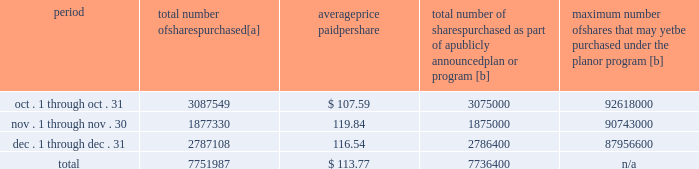Five-year performance comparison 2013 the following graph provides an indicator of cumulative total shareholder returns for the corporation as compared to the peer group index ( described above ) , the dj trans , and the s&p 500 .
The graph assumes that $ 100 was invested in the common stock of union pacific corporation and each index on december 31 , 2009 and that all dividends were reinvested .
The information below is historical in nature and is not necessarily indicative of future performance .
Purchases of equity securities 2013 during 2014 , we repurchased 33035204 shares of our common stock at an average price of $ 100.24 .
The table presents common stock repurchases during each month for the fourth quarter of 2014 : period total number of shares purchased [a] average price paid per share total number of shares purchased as part of a publicly announced plan or program [b] maximum number of shares that may yet be purchased under the plan or program [b] .
[a] total number of shares purchased during the quarter includes approximately 15587 shares delivered or attested to upc by employees to pay stock option exercise prices , satisfy excess tax withholding obligations for stock option exercises or vesting of retention units , and pay withholding obligations for vesting of retention shares .
[b] effective january 1 , 2014 , our board of directors authorized the repurchase of up to 120 million shares of our common stock by december 31 , 2017 .
These repurchases may be made on the open market or through other transactions .
Our management has sole discretion with respect to determining the timing and amount of these transactions. .
What wa the total spent on share repurchases during 2014? 
Computations: (33035204 * 100.24)
Answer: 3311448848.96. 